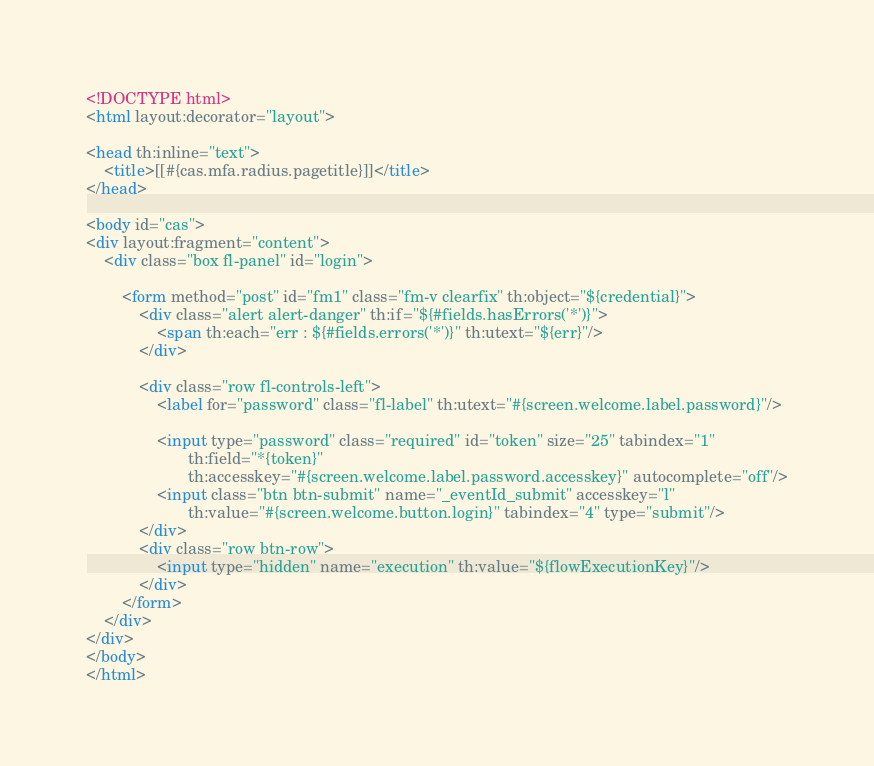<code> <loc_0><loc_0><loc_500><loc_500><_HTML_><!DOCTYPE html>
<html layout:decorator="layout">

<head th:inline="text">
    <title>[[#{cas.mfa.radius.pagetitle}]]</title>
</head>

<body id="cas">
<div layout:fragment="content">
    <div class="box fl-panel" id="login">

        <form method="post" id="fm1" class="fm-v clearfix" th:object="${credential}">
            <div class="alert alert-danger" th:if="${#fields.hasErrors('*')}">
                <span th:each="err : ${#fields.errors('*')}" th:utext="${err}"/>
            </div>

            <div class="row fl-controls-left">
                <label for="password" class="fl-label" th:utext="#{screen.welcome.label.password}"/>

                <input type="password" class="required" id="token" size="25" tabindex="1"
                       th:field="*{token}"
                       th:accesskey="#{screen.welcome.label.password.accesskey}" autocomplete="off"/>
                <input class="btn btn-submit" name="_eventId_submit" accesskey="l"
                       th:value="#{screen.welcome.button.login}" tabindex="4" type="submit"/>
            </div>
            <div class="row btn-row">
                <input type="hidden" name="execution" th:value="${flowExecutionKey}"/>
            </div>
        </form>
    </div>
</div>
</body>
</html>

</code> 